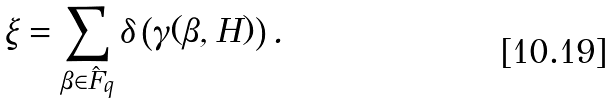Convert formula to latex. <formula><loc_0><loc_0><loc_500><loc_500>\xi = \sum _ { \beta \in \hat { F } _ { q } } \delta \left ( \gamma ( \beta , H ) \right ) .</formula> 